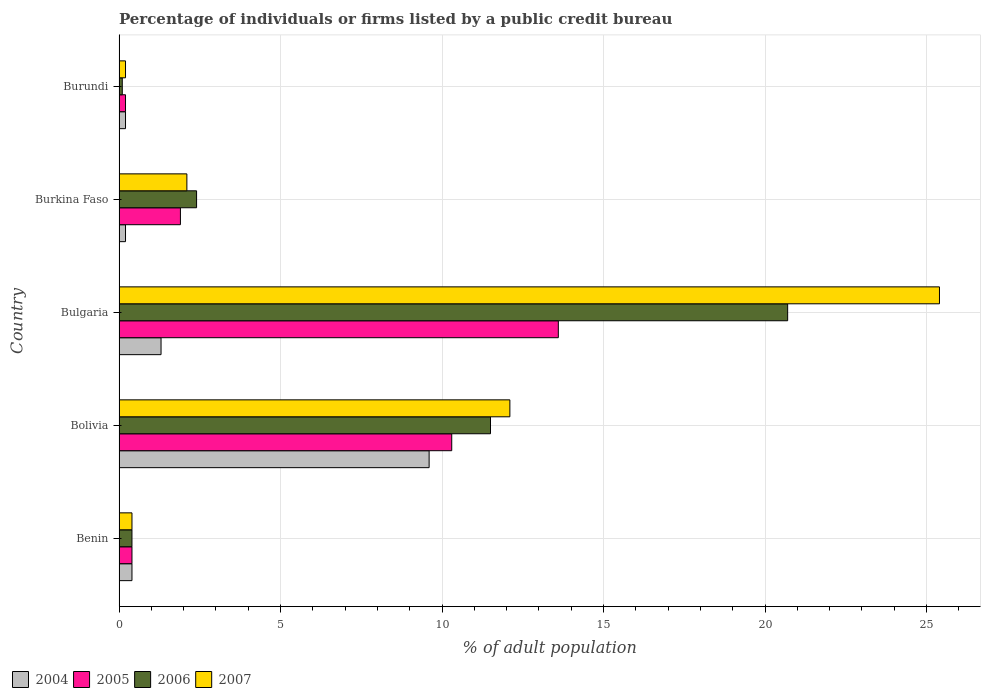How many groups of bars are there?
Your answer should be very brief. 5. Are the number of bars on each tick of the Y-axis equal?
Offer a terse response. Yes. How many bars are there on the 5th tick from the top?
Make the answer very short. 4. What is the label of the 4th group of bars from the top?
Your answer should be very brief. Bolivia. In how many cases, is the number of bars for a given country not equal to the number of legend labels?
Make the answer very short. 0. Across all countries, what is the maximum percentage of population listed by a public credit bureau in 2007?
Ensure brevity in your answer.  25.4. In which country was the percentage of population listed by a public credit bureau in 2005 minimum?
Your response must be concise. Burundi. What is the difference between the percentage of population listed by a public credit bureau in 2005 in Bolivia and the percentage of population listed by a public credit bureau in 2006 in Benin?
Keep it short and to the point. 9.9. What is the average percentage of population listed by a public credit bureau in 2006 per country?
Provide a short and direct response. 7.02. What is the ratio of the percentage of population listed by a public credit bureau in 2005 in Bolivia to that in Burundi?
Your answer should be very brief. 51.5. What is the difference between the highest and the second highest percentage of population listed by a public credit bureau in 2007?
Your response must be concise. 13.3. What is the difference between the highest and the lowest percentage of population listed by a public credit bureau in 2007?
Offer a terse response. 25.2. Is it the case that in every country, the sum of the percentage of population listed by a public credit bureau in 2007 and percentage of population listed by a public credit bureau in 2005 is greater than the sum of percentage of population listed by a public credit bureau in 2006 and percentage of population listed by a public credit bureau in 2004?
Ensure brevity in your answer.  No. What does the 2nd bar from the top in Burundi represents?
Offer a very short reply. 2006. Is it the case that in every country, the sum of the percentage of population listed by a public credit bureau in 2004 and percentage of population listed by a public credit bureau in 2007 is greater than the percentage of population listed by a public credit bureau in 2005?
Provide a short and direct response. Yes. How many bars are there?
Offer a terse response. 20. Are all the bars in the graph horizontal?
Your answer should be compact. Yes. What is the difference between two consecutive major ticks on the X-axis?
Offer a terse response. 5. Are the values on the major ticks of X-axis written in scientific E-notation?
Provide a succinct answer. No. Where does the legend appear in the graph?
Your answer should be very brief. Bottom left. What is the title of the graph?
Your response must be concise. Percentage of individuals or firms listed by a public credit bureau. Does "1977" appear as one of the legend labels in the graph?
Provide a succinct answer. No. What is the label or title of the X-axis?
Make the answer very short. % of adult population. What is the % of adult population in 2004 in Benin?
Provide a short and direct response. 0.4. What is the % of adult population in 2005 in Benin?
Offer a terse response. 0.4. What is the % of adult population in 2006 in Benin?
Your answer should be compact. 0.4. What is the % of adult population in 2006 in Bolivia?
Give a very brief answer. 11.5. What is the % of adult population in 2004 in Bulgaria?
Offer a very short reply. 1.3. What is the % of adult population in 2006 in Bulgaria?
Provide a short and direct response. 20.7. What is the % of adult population in 2007 in Bulgaria?
Give a very brief answer. 25.4. What is the % of adult population of 2005 in Burundi?
Keep it short and to the point. 0.2. What is the % of adult population of 2006 in Burundi?
Your answer should be very brief. 0.1. Across all countries, what is the maximum % of adult population in 2004?
Provide a succinct answer. 9.6. Across all countries, what is the maximum % of adult population of 2006?
Provide a succinct answer. 20.7. Across all countries, what is the maximum % of adult population in 2007?
Offer a terse response. 25.4. Across all countries, what is the minimum % of adult population in 2004?
Your answer should be compact. 0.2. Across all countries, what is the minimum % of adult population in 2005?
Make the answer very short. 0.2. Across all countries, what is the minimum % of adult population in 2007?
Keep it short and to the point. 0.2. What is the total % of adult population of 2005 in the graph?
Make the answer very short. 26.4. What is the total % of adult population in 2006 in the graph?
Make the answer very short. 35.1. What is the total % of adult population of 2007 in the graph?
Keep it short and to the point. 40.2. What is the difference between the % of adult population in 2004 in Benin and that in Bolivia?
Give a very brief answer. -9.2. What is the difference between the % of adult population in 2005 in Benin and that in Bolivia?
Make the answer very short. -9.9. What is the difference between the % of adult population of 2004 in Benin and that in Bulgaria?
Your answer should be very brief. -0.9. What is the difference between the % of adult population in 2005 in Benin and that in Bulgaria?
Make the answer very short. -13.2. What is the difference between the % of adult population of 2006 in Benin and that in Bulgaria?
Offer a very short reply. -20.3. What is the difference between the % of adult population of 2007 in Benin and that in Bulgaria?
Your answer should be very brief. -25. What is the difference between the % of adult population in 2004 in Benin and that in Burkina Faso?
Give a very brief answer. 0.2. What is the difference between the % of adult population in 2005 in Benin and that in Burkina Faso?
Offer a terse response. -1.5. What is the difference between the % of adult population in 2004 in Benin and that in Burundi?
Keep it short and to the point. 0.2. What is the difference between the % of adult population of 2005 in Benin and that in Burundi?
Your response must be concise. 0.2. What is the difference between the % of adult population of 2006 in Benin and that in Burundi?
Your answer should be compact. 0.3. What is the difference between the % of adult population of 2007 in Benin and that in Burundi?
Give a very brief answer. 0.2. What is the difference between the % of adult population of 2004 in Bolivia and that in Bulgaria?
Offer a terse response. 8.3. What is the difference between the % of adult population of 2005 in Bolivia and that in Bulgaria?
Your response must be concise. -3.3. What is the difference between the % of adult population in 2004 in Bolivia and that in Burkina Faso?
Provide a short and direct response. 9.4. What is the difference between the % of adult population of 2005 in Bolivia and that in Burkina Faso?
Give a very brief answer. 8.4. What is the difference between the % of adult population of 2006 in Bolivia and that in Burkina Faso?
Offer a very short reply. 9.1. What is the difference between the % of adult population of 2007 in Bolivia and that in Burkina Faso?
Provide a succinct answer. 10. What is the difference between the % of adult population of 2004 in Bolivia and that in Burundi?
Keep it short and to the point. 9.4. What is the difference between the % of adult population in 2005 in Bolivia and that in Burundi?
Provide a short and direct response. 10.1. What is the difference between the % of adult population of 2005 in Bulgaria and that in Burkina Faso?
Keep it short and to the point. 11.7. What is the difference between the % of adult population of 2007 in Bulgaria and that in Burkina Faso?
Ensure brevity in your answer.  23.3. What is the difference between the % of adult population in 2005 in Bulgaria and that in Burundi?
Give a very brief answer. 13.4. What is the difference between the % of adult population in 2006 in Bulgaria and that in Burundi?
Your answer should be very brief. 20.6. What is the difference between the % of adult population in 2007 in Bulgaria and that in Burundi?
Your answer should be compact. 25.2. What is the difference between the % of adult population of 2005 in Burkina Faso and that in Burundi?
Your answer should be very brief. 1.7. What is the difference between the % of adult population of 2006 in Benin and the % of adult population of 2007 in Bolivia?
Provide a short and direct response. -11.7. What is the difference between the % of adult population in 2004 in Benin and the % of adult population in 2006 in Bulgaria?
Your answer should be very brief. -20.3. What is the difference between the % of adult population in 2005 in Benin and the % of adult population in 2006 in Bulgaria?
Provide a short and direct response. -20.3. What is the difference between the % of adult population of 2004 in Benin and the % of adult population of 2007 in Burkina Faso?
Keep it short and to the point. -1.7. What is the difference between the % of adult population in 2005 in Benin and the % of adult population in 2007 in Burkina Faso?
Provide a short and direct response. -1.7. What is the difference between the % of adult population of 2005 in Benin and the % of adult population of 2006 in Burundi?
Provide a succinct answer. 0.3. What is the difference between the % of adult population in 2005 in Benin and the % of adult population in 2007 in Burundi?
Offer a terse response. 0.2. What is the difference between the % of adult population in 2004 in Bolivia and the % of adult population in 2005 in Bulgaria?
Give a very brief answer. -4. What is the difference between the % of adult population in 2004 in Bolivia and the % of adult population in 2007 in Bulgaria?
Your response must be concise. -15.8. What is the difference between the % of adult population in 2005 in Bolivia and the % of adult population in 2006 in Bulgaria?
Your answer should be compact. -10.4. What is the difference between the % of adult population of 2005 in Bolivia and the % of adult population of 2007 in Bulgaria?
Offer a very short reply. -15.1. What is the difference between the % of adult population in 2004 in Bolivia and the % of adult population in 2006 in Burkina Faso?
Offer a very short reply. 7.2. What is the difference between the % of adult population in 2005 in Bolivia and the % of adult population in 2006 in Burkina Faso?
Make the answer very short. 7.9. What is the difference between the % of adult population in 2005 in Bolivia and the % of adult population in 2007 in Burkina Faso?
Keep it short and to the point. 8.2. What is the difference between the % of adult population in 2004 in Bolivia and the % of adult population in 2005 in Burundi?
Your answer should be very brief. 9.4. What is the difference between the % of adult population of 2005 in Bolivia and the % of adult population of 2006 in Burundi?
Give a very brief answer. 10.2. What is the difference between the % of adult population of 2005 in Bolivia and the % of adult population of 2007 in Burundi?
Your response must be concise. 10.1. What is the difference between the % of adult population in 2006 in Bolivia and the % of adult population in 2007 in Burundi?
Provide a succinct answer. 11.3. What is the difference between the % of adult population of 2004 in Bulgaria and the % of adult population of 2005 in Burkina Faso?
Make the answer very short. -0.6. What is the difference between the % of adult population in 2004 in Bulgaria and the % of adult population in 2007 in Burkina Faso?
Offer a very short reply. -0.8. What is the difference between the % of adult population in 2005 in Bulgaria and the % of adult population in 2006 in Burkina Faso?
Provide a succinct answer. 11.2. What is the difference between the % of adult population of 2005 in Bulgaria and the % of adult population of 2007 in Burkina Faso?
Provide a short and direct response. 11.5. What is the difference between the % of adult population of 2006 in Bulgaria and the % of adult population of 2007 in Burkina Faso?
Provide a short and direct response. 18.6. What is the difference between the % of adult population in 2005 in Bulgaria and the % of adult population in 2006 in Burundi?
Give a very brief answer. 13.5. What is the difference between the % of adult population in 2005 in Bulgaria and the % of adult population in 2007 in Burundi?
Ensure brevity in your answer.  13.4. What is the difference between the % of adult population of 2006 in Bulgaria and the % of adult population of 2007 in Burundi?
Ensure brevity in your answer.  20.5. What is the difference between the % of adult population in 2004 in Burkina Faso and the % of adult population in 2005 in Burundi?
Give a very brief answer. 0. What is the difference between the % of adult population in 2005 in Burkina Faso and the % of adult population in 2006 in Burundi?
Your answer should be compact. 1.8. What is the difference between the % of adult population of 2005 in Burkina Faso and the % of adult population of 2007 in Burundi?
Make the answer very short. 1.7. What is the average % of adult population in 2004 per country?
Provide a short and direct response. 2.34. What is the average % of adult population of 2005 per country?
Offer a very short reply. 5.28. What is the average % of adult population in 2006 per country?
Your answer should be compact. 7.02. What is the average % of adult population in 2007 per country?
Offer a very short reply. 8.04. What is the difference between the % of adult population in 2004 and % of adult population in 2005 in Benin?
Your answer should be compact. 0. What is the difference between the % of adult population in 2004 and % of adult population in 2006 in Benin?
Offer a terse response. 0. What is the difference between the % of adult population in 2005 and % of adult population in 2007 in Benin?
Your answer should be compact. 0. What is the difference between the % of adult population of 2006 and % of adult population of 2007 in Benin?
Provide a short and direct response. 0. What is the difference between the % of adult population of 2004 and % of adult population of 2005 in Bolivia?
Your answer should be compact. -0.7. What is the difference between the % of adult population of 2004 and % of adult population of 2006 in Bolivia?
Your answer should be very brief. -1.9. What is the difference between the % of adult population in 2006 and % of adult population in 2007 in Bolivia?
Ensure brevity in your answer.  -0.6. What is the difference between the % of adult population of 2004 and % of adult population of 2006 in Bulgaria?
Keep it short and to the point. -19.4. What is the difference between the % of adult population in 2004 and % of adult population in 2007 in Bulgaria?
Offer a terse response. -24.1. What is the difference between the % of adult population of 2005 and % of adult population of 2006 in Bulgaria?
Your answer should be very brief. -7.1. What is the difference between the % of adult population in 2004 and % of adult population in 2005 in Burkina Faso?
Your response must be concise. -1.7. What is the difference between the % of adult population of 2004 and % of adult population of 2007 in Burkina Faso?
Your response must be concise. -1.9. What is the difference between the % of adult population of 2005 and % of adult population of 2006 in Burkina Faso?
Offer a very short reply. -0.5. What is the difference between the % of adult population in 2005 and % of adult population in 2007 in Burkina Faso?
Offer a terse response. -0.2. What is the difference between the % of adult population in 2006 and % of adult population in 2007 in Burkina Faso?
Your response must be concise. 0.3. What is the difference between the % of adult population of 2004 and % of adult population of 2006 in Burundi?
Make the answer very short. 0.1. What is the ratio of the % of adult population in 2004 in Benin to that in Bolivia?
Offer a terse response. 0.04. What is the ratio of the % of adult population of 2005 in Benin to that in Bolivia?
Make the answer very short. 0.04. What is the ratio of the % of adult population in 2006 in Benin to that in Bolivia?
Ensure brevity in your answer.  0.03. What is the ratio of the % of adult population of 2007 in Benin to that in Bolivia?
Provide a short and direct response. 0.03. What is the ratio of the % of adult population in 2004 in Benin to that in Bulgaria?
Give a very brief answer. 0.31. What is the ratio of the % of adult population in 2005 in Benin to that in Bulgaria?
Ensure brevity in your answer.  0.03. What is the ratio of the % of adult population of 2006 in Benin to that in Bulgaria?
Give a very brief answer. 0.02. What is the ratio of the % of adult population in 2007 in Benin to that in Bulgaria?
Provide a short and direct response. 0.02. What is the ratio of the % of adult population of 2005 in Benin to that in Burkina Faso?
Offer a very short reply. 0.21. What is the ratio of the % of adult population of 2006 in Benin to that in Burkina Faso?
Make the answer very short. 0.17. What is the ratio of the % of adult population of 2007 in Benin to that in Burkina Faso?
Your answer should be compact. 0.19. What is the ratio of the % of adult population of 2006 in Benin to that in Burundi?
Your response must be concise. 4. What is the ratio of the % of adult population of 2004 in Bolivia to that in Bulgaria?
Offer a very short reply. 7.38. What is the ratio of the % of adult population in 2005 in Bolivia to that in Bulgaria?
Give a very brief answer. 0.76. What is the ratio of the % of adult population in 2006 in Bolivia to that in Bulgaria?
Keep it short and to the point. 0.56. What is the ratio of the % of adult population of 2007 in Bolivia to that in Bulgaria?
Ensure brevity in your answer.  0.48. What is the ratio of the % of adult population in 2004 in Bolivia to that in Burkina Faso?
Your answer should be very brief. 48. What is the ratio of the % of adult population of 2005 in Bolivia to that in Burkina Faso?
Ensure brevity in your answer.  5.42. What is the ratio of the % of adult population of 2006 in Bolivia to that in Burkina Faso?
Your response must be concise. 4.79. What is the ratio of the % of adult population of 2007 in Bolivia to that in Burkina Faso?
Ensure brevity in your answer.  5.76. What is the ratio of the % of adult population of 2005 in Bolivia to that in Burundi?
Your answer should be very brief. 51.5. What is the ratio of the % of adult population of 2006 in Bolivia to that in Burundi?
Make the answer very short. 115. What is the ratio of the % of adult population in 2007 in Bolivia to that in Burundi?
Ensure brevity in your answer.  60.5. What is the ratio of the % of adult population of 2005 in Bulgaria to that in Burkina Faso?
Ensure brevity in your answer.  7.16. What is the ratio of the % of adult population of 2006 in Bulgaria to that in Burkina Faso?
Provide a short and direct response. 8.62. What is the ratio of the % of adult population of 2007 in Bulgaria to that in Burkina Faso?
Offer a terse response. 12.1. What is the ratio of the % of adult population of 2004 in Bulgaria to that in Burundi?
Your answer should be very brief. 6.5. What is the ratio of the % of adult population in 2005 in Bulgaria to that in Burundi?
Your answer should be compact. 68. What is the ratio of the % of adult population in 2006 in Bulgaria to that in Burundi?
Keep it short and to the point. 207. What is the ratio of the % of adult population in 2007 in Bulgaria to that in Burundi?
Make the answer very short. 127. What is the ratio of the % of adult population in 2006 in Burkina Faso to that in Burundi?
Offer a very short reply. 24. What is the ratio of the % of adult population in 2007 in Burkina Faso to that in Burundi?
Ensure brevity in your answer.  10.5. What is the difference between the highest and the second highest % of adult population of 2004?
Provide a succinct answer. 8.3. What is the difference between the highest and the second highest % of adult population in 2007?
Provide a short and direct response. 13.3. What is the difference between the highest and the lowest % of adult population of 2004?
Offer a terse response. 9.4. What is the difference between the highest and the lowest % of adult population in 2006?
Ensure brevity in your answer.  20.6. What is the difference between the highest and the lowest % of adult population of 2007?
Ensure brevity in your answer.  25.2. 